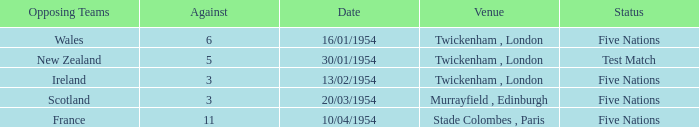On january 16, 1954, where did the game take place when the rival team had more than 3 points? Twickenham , London. 